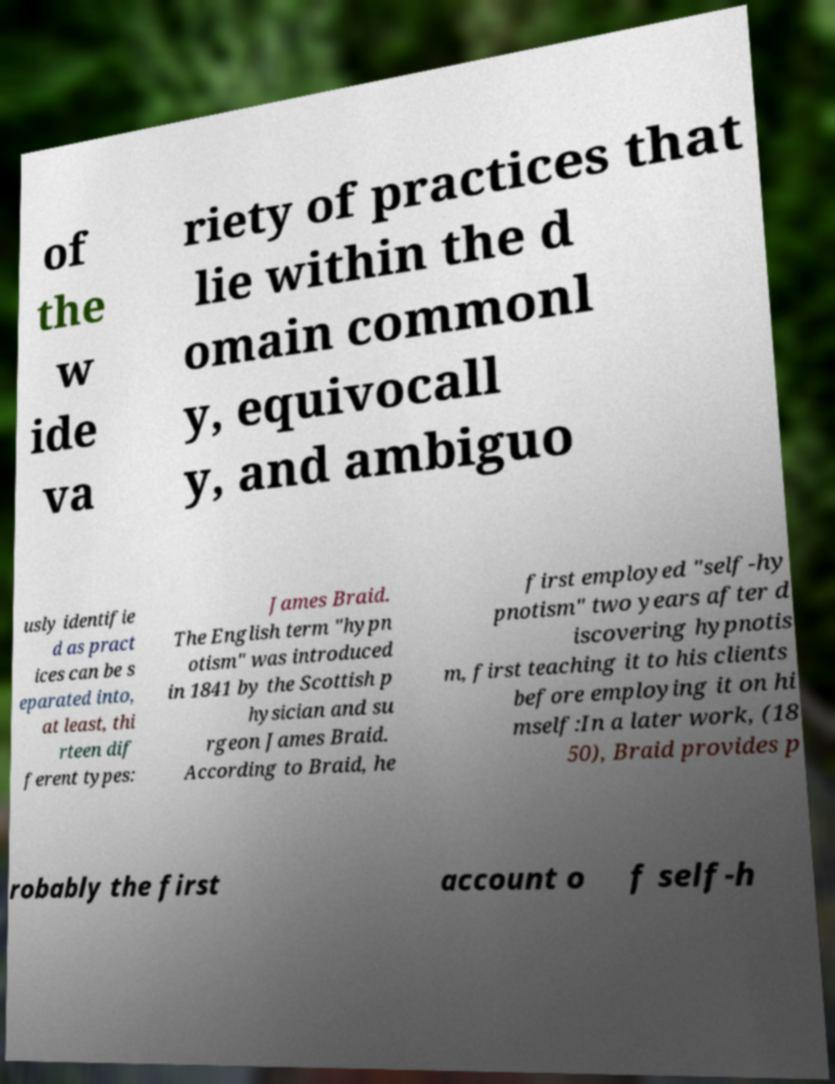For documentation purposes, I need the text within this image transcribed. Could you provide that? of the w ide va riety of practices that lie within the d omain commonl y, equivocall y, and ambiguo usly identifie d as pract ices can be s eparated into, at least, thi rteen dif ferent types: James Braid. The English term "hypn otism" was introduced in 1841 by the Scottish p hysician and su rgeon James Braid. According to Braid, he first employed "self-hy pnotism" two years after d iscovering hypnotis m, first teaching it to his clients before employing it on hi mself:In a later work, (18 50), Braid provides p robably the first account o f self-h 